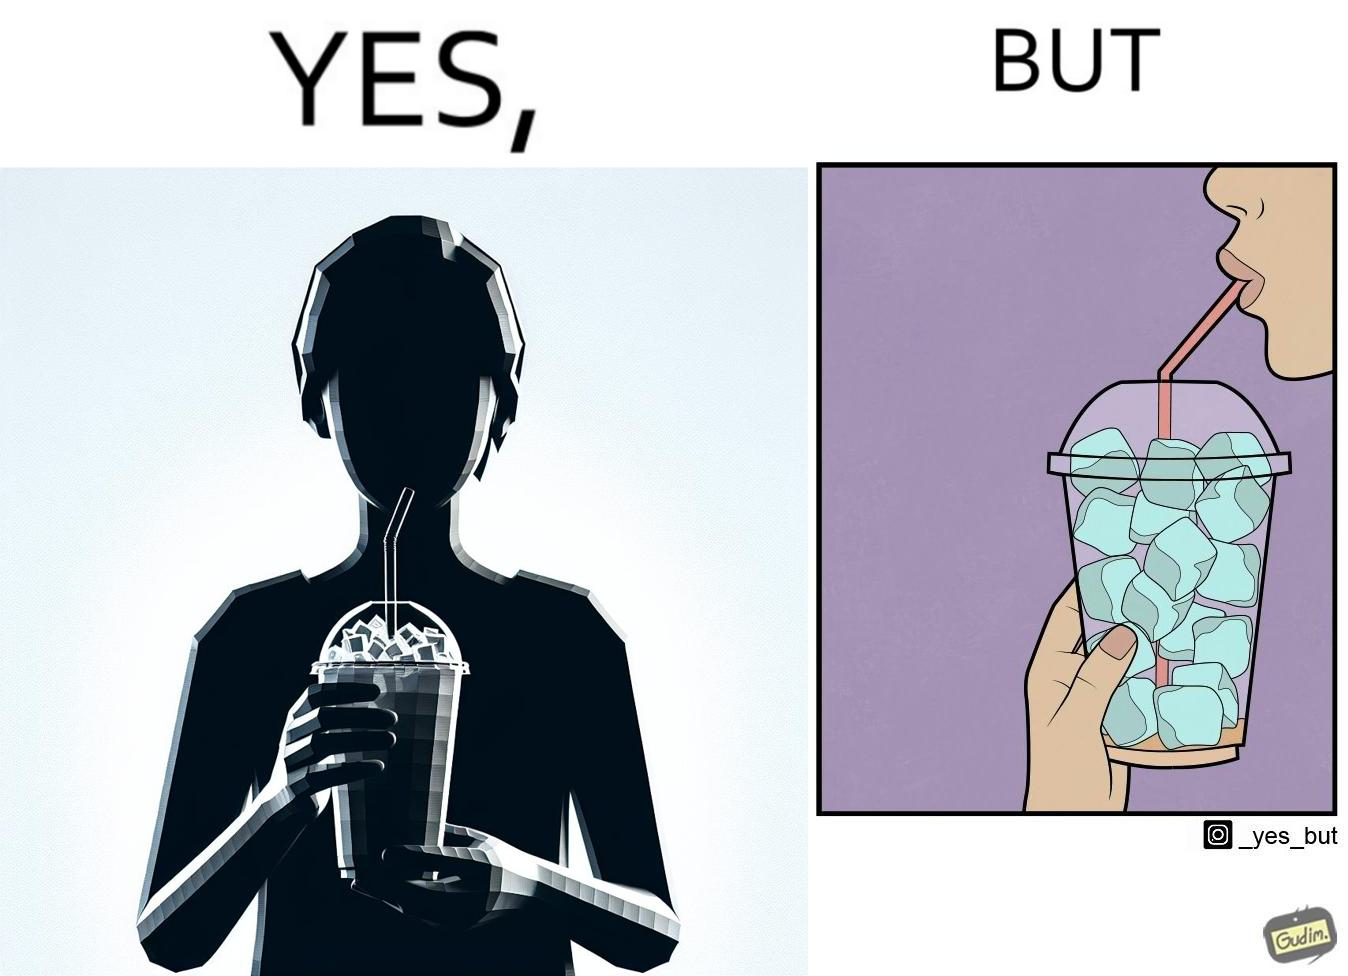What is shown in the left half versus the right half of this image? In the left part of the image: A person holding a drink with ice cubes, with a straw in the drink. In the right part of the image: A person drinking out of a straw from a drink. The drink is almost finished, and only I've cubes are left. 